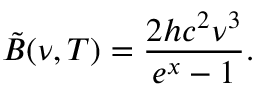Convert formula to latex. <formula><loc_0><loc_0><loc_500><loc_500>\tilde { B } ( \nu , T ) = { \frac { 2 h c ^ { 2 } \nu ^ { 3 } } { e ^ { x } - 1 } } .</formula> 